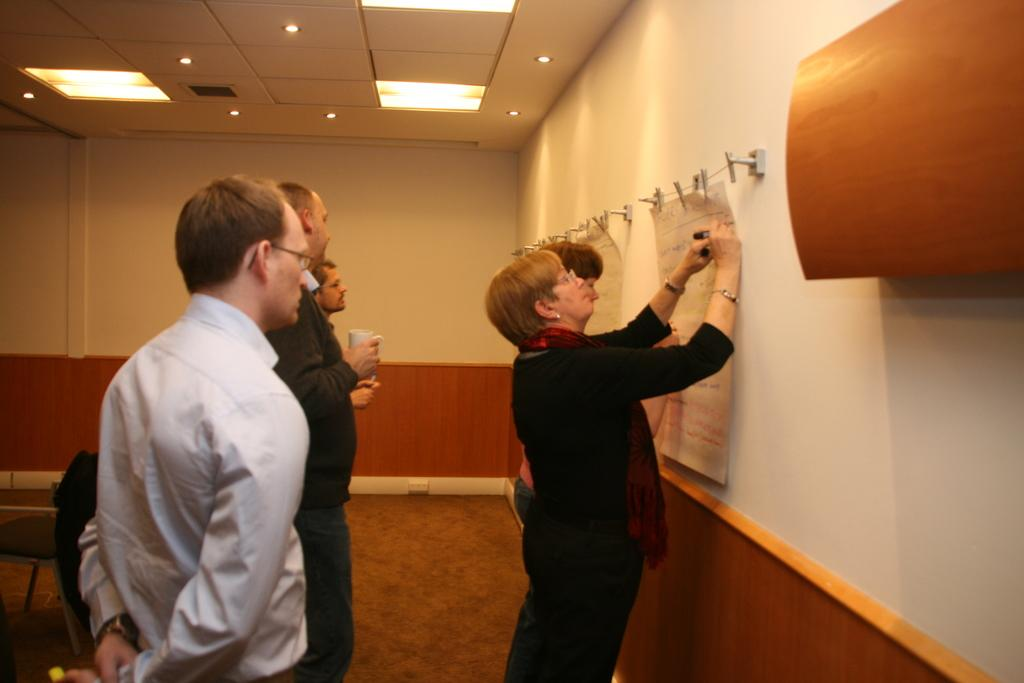What can be seen on the right side of the image? There is a wall on the right side of the image. What are the persons in the image doing? The persons are standing in front of the wall. What is the woman in the image doing specifically? The woman is fixing a paper to the wall. Can you see any smoke coming from the wall in the image? No, there is no smoke present in the image. Are the persons in the image friends? The provided facts do not give any information about the relationship between the persons in the image, so we cannot determine if they are friends. 